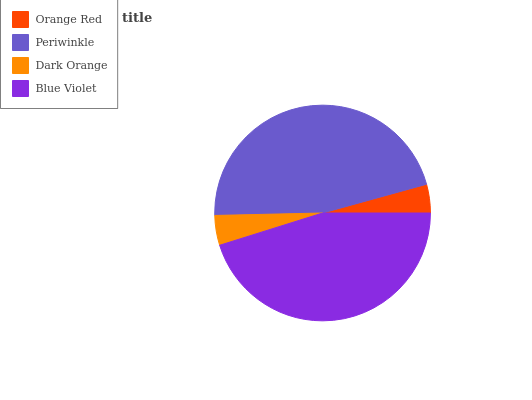Is Orange Red the minimum?
Answer yes or no. Yes. Is Periwinkle the maximum?
Answer yes or no. Yes. Is Dark Orange the minimum?
Answer yes or no. No. Is Dark Orange the maximum?
Answer yes or no. No. Is Periwinkle greater than Dark Orange?
Answer yes or no. Yes. Is Dark Orange less than Periwinkle?
Answer yes or no. Yes. Is Dark Orange greater than Periwinkle?
Answer yes or no. No. Is Periwinkle less than Dark Orange?
Answer yes or no. No. Is Blue Violet the high median?
Answer yes or no. Yes. Is Dark Orange the low median?
Answer yes or no. Yes. Is Periwinkle the high median?
Answer yes or no. No. Is Periwinkle the low median?
Answer yes or no. No. 